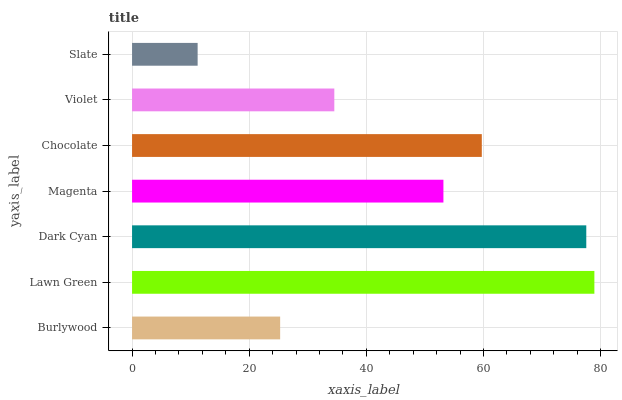Is Slate the minimum?
Answer yes or no. Yes. Is Lawn Green the maximum?
Answer yes or no. Yes. Is Dark Cyan the minimum?
Answer yes or no. No. Is Dark Cyan the maximum?
Answer yes or no. No. Is Lawn Green greater than Dark Cyan?
Answer yes or no. Yes. Is Dark Cyan less than Lawn Green?
Answer yes or no. Yes. Is Dark Cyan greater than Lawn Green?
Answer yes or no. No. Is Lawn Green less than Dark Cyan?
Answer yes or no. No. Is Magenta the high median?
Answer yes or no. Yes. Is Magenta the low median?
Answer yes or no. Yes. Is Chocolate the high median?
Answer yes or no. No. Is Burlywood the low median?
Answer yes or no. No. 